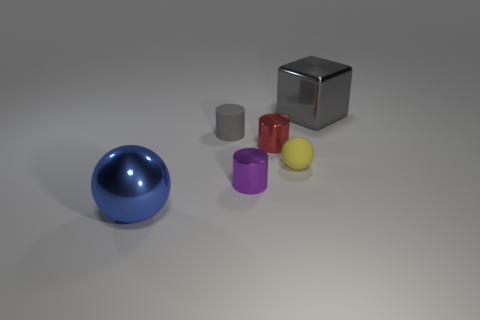Can you tell me the colors of the objects starting from the largest to the smallest? Certainly! Starting with the largest, we have blue, silver, yellow, purple, and then red. 